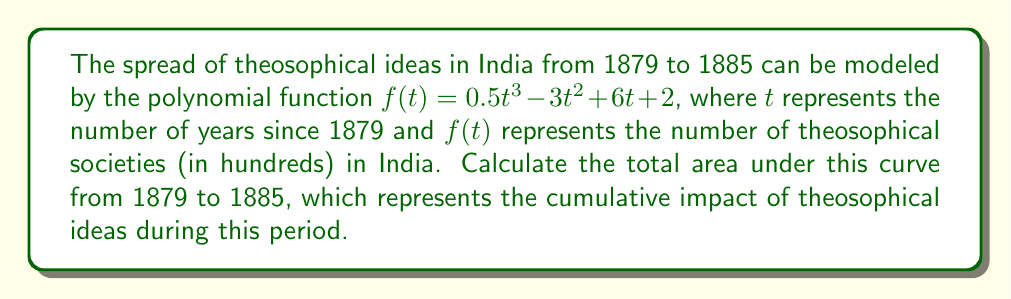What is the answer to this math problem? To calculate the area under the curve, we need to integrate the function $f(t)$ from $t=0$ (1879) to $t=6$ (1885):

1) The integral is:
   $$\int_0^6 (0.5t^3 - 3t^2 + 6t + 2) dt$$

2) Integrate each term:
   $$\left[\frac{0.5t^4}{4} - t^3 + 3t^2 + 2t\right]_0^6$$

3) Evaluate at the upper and lower bounds:
   $$\left(\frac{0.5(6^4)}{4} - 6^3 + 3(6^2) + 2(6)\right) - \left(\frac{0.5(0^4)}{4} - 0^3 + 3(0^2) + 2(0)\right)$$

4) Simplify:
   $$(81 - 216 + 108 + 12) - (0)$$

5) Calculate:
   $$-15 - 0 = -15$$

6) Interpret: The negative result indicates the area below the x-axis exceeds the area above it. The absolute value represents the net area.

7) Convert to hundreds of theosophical societies:
   $15 * 100 = 1500$
Answer: 1500 theosophical societies 